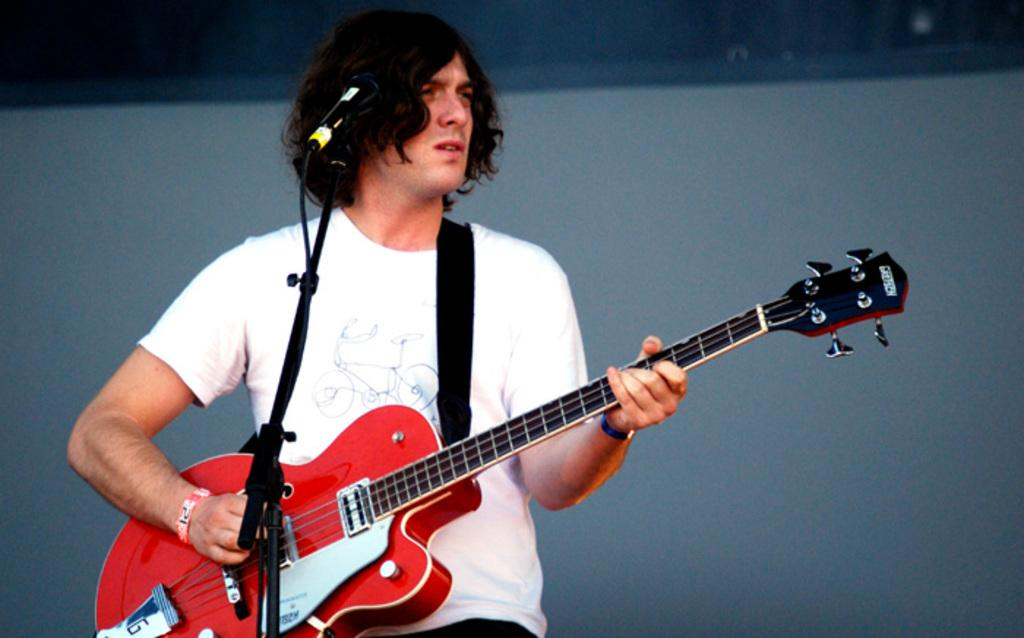Who is the main subject in the image? There is a man in the image. What is the man wearing? The man is wearing a white t-shirt. What is the man holding in the image? The man is holding a guitar. What is the man doing with the guitar? The man is playing the guitar. What object is in front of the man? There is a microphone in front of the man. What type of hammer can be seen in the man's hand in the image? There is no hammer present in the image; the man is holding a guitar. How does the man stop playing the guitar in the image? The image does not show the man stopping playing the guitar, only him playing it. 